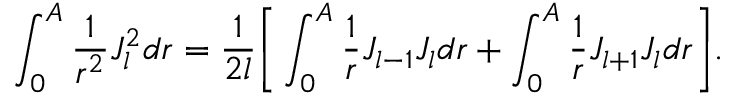Convert formula to latex. <formula><loc_0><loc_0><loc_500><loc_500>\int _ { 0 } ^ { A } \frac { 1 } { r ^ { 2 } } J _ { l } ^ { 2 } d r = \frac { 1 } { 2 l } \left [ \int _ { 0 } ^ { A } \frac { 1 } { r } J _ { l - 1 } J _ { l } d r + \int _ { 0 } ^ { A } \frac { 1 } { r } J _ { l + 1 } J _ { l } d r \right ] .</formula> 